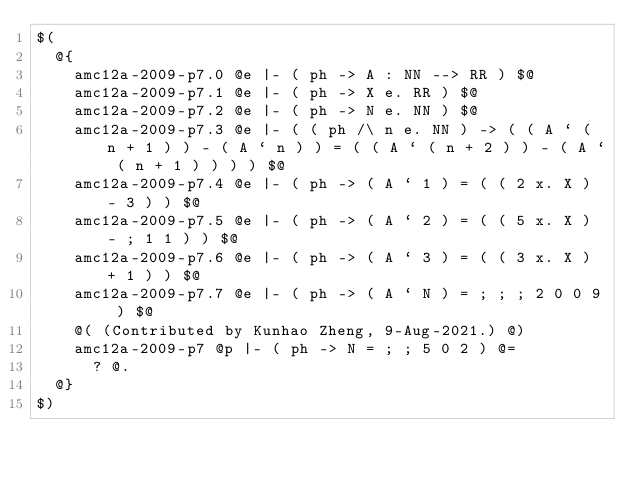Convert code to text. <code><loc_0><loc_0><loc_500><loc_500><_ObjectiveC_>$(
  @{
    amc12a-2009-p7.0 @e |- ( ph -> A : NN --> RR ) $@
    amc12a-2009-p7.1 @e |- ( ph -> X e. RR ) $@
    amc12a-2009-p7.2 @e |- ( ph -> N e. NN ) $@
    amc12a-2009-p7.3 @e |- ( ( ph /\ n e. NN ) -> ( ( A ` ( n + 1 ) ) - ( A ` n ) ) = ( ( A ` ( n + 2 ) ) - ( A ` ( n + 1 ) ) ) ) $@
    amc12a-2009-p7.4 @e |- ( ph -> ( A ` 1 ) = ( ( 2 x. X ) - 3 ) ) $@
    amc12a-2009-p7.5 @e |- ( ph -> ( A ` 2 ) = ( ( 5 x. X ) - ; 1 1 ) ) $@
    amc12a-2009-p7.6 @e |- ( ph -> ( A ` 3 ) = ( ( 3 x. X ) + 1 ) ) $@
    amc12a-2009-p7.7 @e |- ( ph -> ( A ` N ) = ; ; ; 2 0 0 9 ) $@
    @( (Contributed by Kunhao Zheng, 9-Aug-2021.) @)
    amc12a-2009-p7 @p |- ( ph -> N = ; ; 5 0 2 ) @=
      ? @.
  @}
$)
</code> 